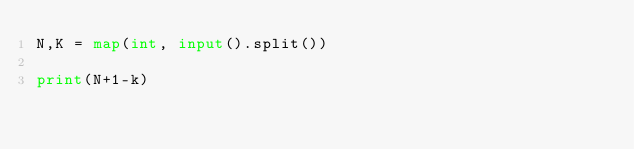<code> <loc_0><loc_0><loc_500><loc_500><_Python_>N,K = map(int, input().split())

print(N+1-k)
</code> 